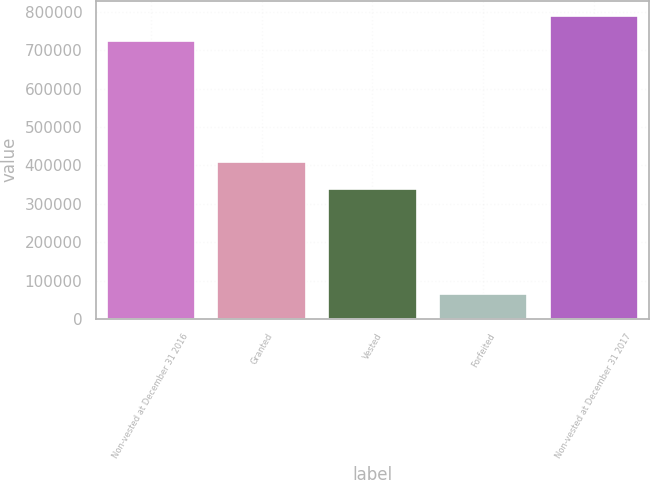Convert chart. <chart><loc_0><loc_0><loc_500><loc_500><bar_chart><fcel>Non-vested at December 31 2016<fcel>Granted<fcel>Vested<fcel>Forfeited<fcel>Non-vested at December 31 2017<nl><fcel>723398<fcel>408608<fcel>338988<fcel>64953<fcel>789709<nl></chart> 